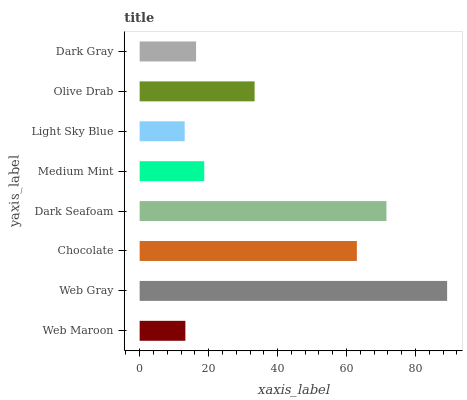Is Light Sky Blue the minimum?
Answer yes or no. Yes. Is Web Gray the maximum?
Answer yes or no. Yes. Is Chocolate the minimum?
Answer yes or no. No. Is Chocolate the maximum?
Answer yes or no. No. Is Web Gray greater than Chocolate?
Answer yes or no. Yes. Is Chocolate less than Web Gray?
Answer yes or no. Yes. Is Chocolate greater than Web Gray?
Answer yes or no. No. Is Web Gray less than Chocolate?
Answer yes or no. No. Is Olive Drab the high median?
Answer yes or no. Yes. Is Medium Mint the low median?
Answer yes or no. Yes. Is Chocolate the high median?
Answer yes or no. No. Is Chocolate the low median?
Answer yes or no. No. 